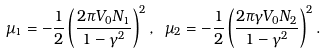<formula> <loc_0><loc_0><loc_500><loc_500>\mu _ { 1 } = - \frac { 1 } { 2 } \left ( \frac { 2 \pi V _ { 0 } N _ { 1 } } { 1 - \gamma ^ { 2 } } \right ) ^ { 2 } , \ \mu _ { 2 } = - \frac { 1 } { 2 } \left ( \frac { 2 \pi \gamma V _ { 0 } N _ { 2 } } { 1 - \gamma ^ { 2 } } \right ) ^ { 2 } .</formula> 